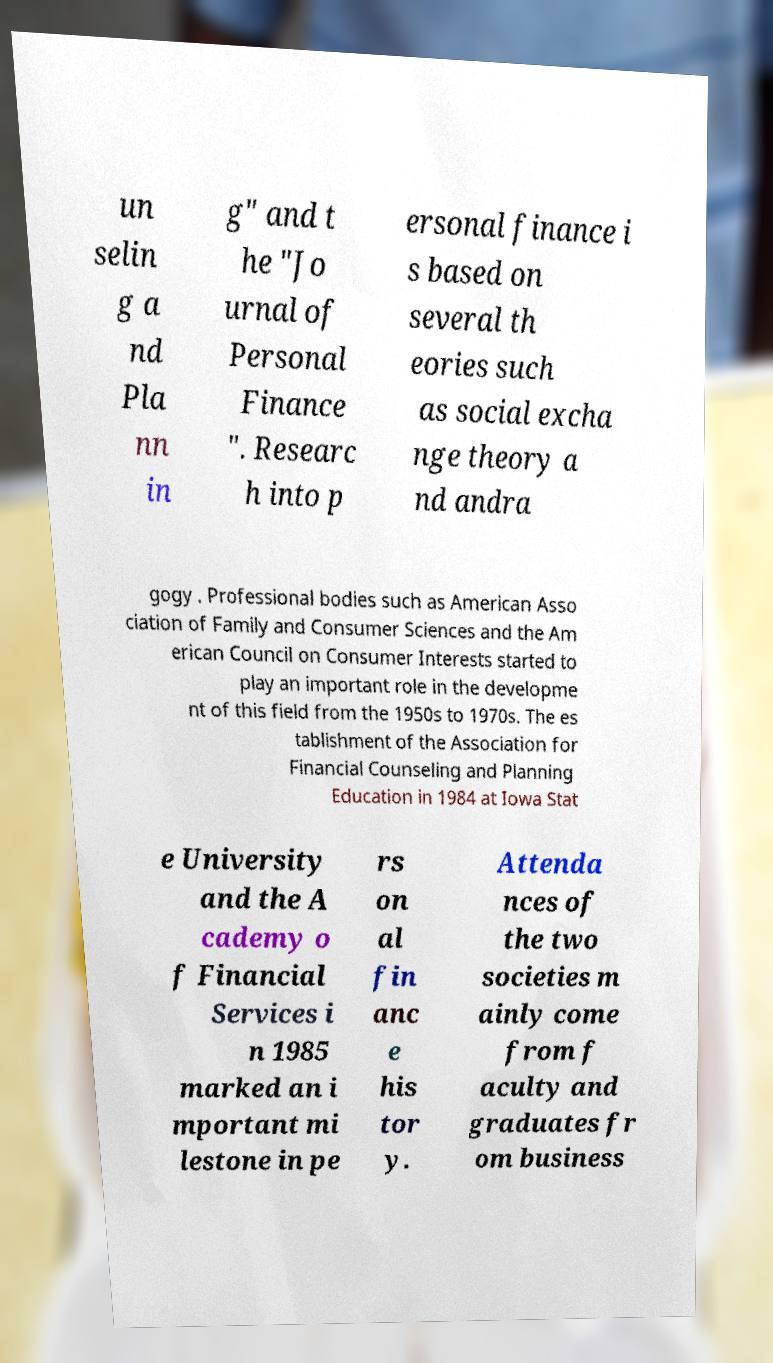There's text embedded in this image that I need extracted. Can you transcribe it verbatim? un selin g a nd Pla nn in g" and t he "Jo urnal of Personal Finance ". Researc h into p ersonal finance i s based on several th eories such as social excha nge theory a nd andra gogy . Professional bodies such as American Asso ciation of Family and Consumer Sciences and the Am erican Council on Consumer Interests started to play an important role in the developme nt of this field from the 1950s to 1970s. The es tablishment of the Association for Financial Counseling and Planning Education in 1984 at Iowa Stat e University and the A cademy o f Financial Services i n 1985 marked an i mportant mi lestone in pe rs on al fin anc e his tor y. Attenda nces of the two societies m ainly come from f aculty and graduates fr om business 